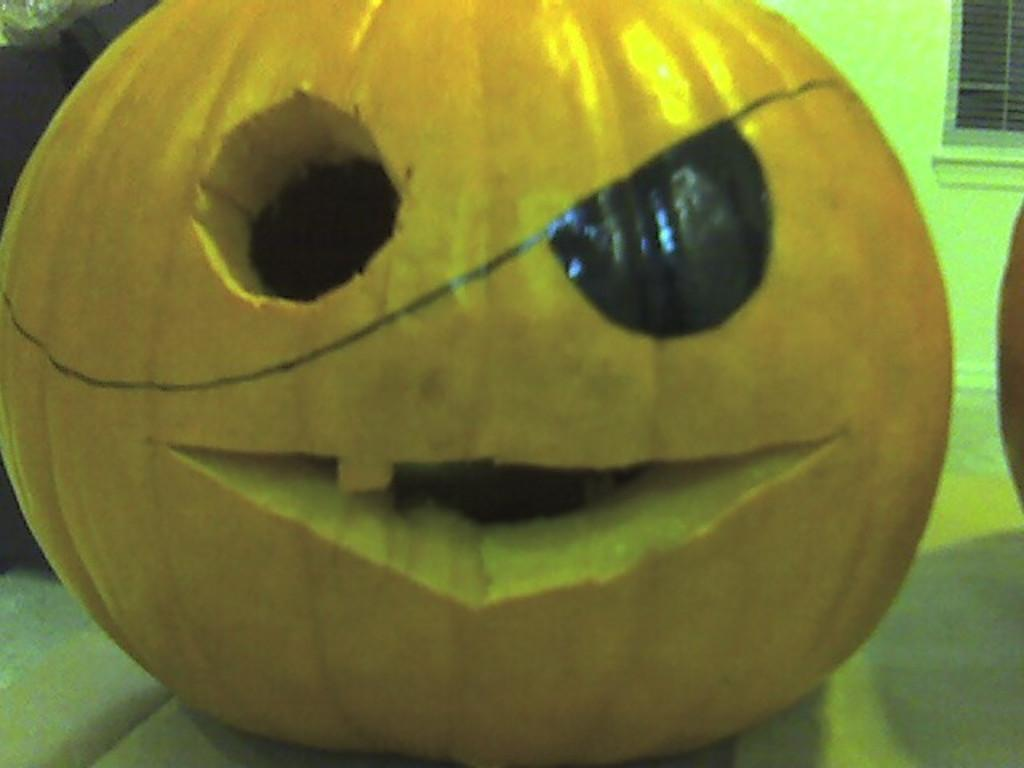What is the main object in the image? There is a pumpkin in the image. How has the pumpkin been modified? The pumpkin has an eye and mouth carved into it. What can be seen in the background of the image? There is a wall and a window in the background of the image. What type of teeth can be seen in the pumpkin's mouth in the image? There are no teeth present in the pumpkin's mouth in the image, as it is a carved design and not an actual mouth. 